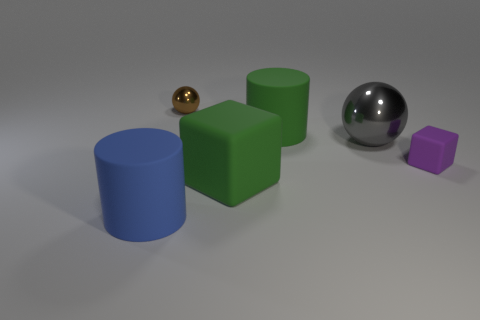Subtract all balls. How many objects are left? 4 Add 3 small brown metal spheres. How many small brown metal spheres are left? 4 Add 2 big things. How many big things exist? 6 Add 1 big brown objects. How many objects exist? 7 Subtract 1 purple cubes. How many objects are left? 5 Subtract 1 cylinders. How many cylinders are left? 1 Subtract all green cylinders. Subtract all purple balls. How many cylinders are left? 1 Subtract all red cylinders. How many purple blocks are left? 1 Subtract all big red metallic cylinders. Subtract all large spheres. How many objects are left? 5 